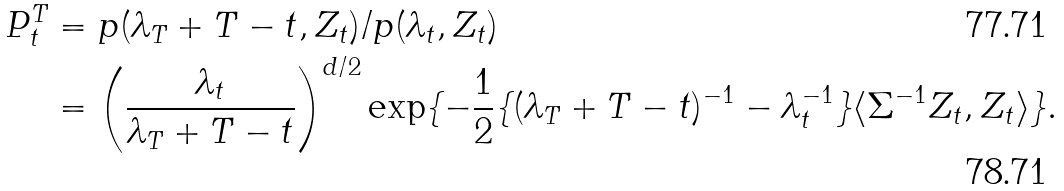Convert formula to latex. <formula><loc_0><loc_0><loc_500><loc_500>P ^ { T } _ { t } & = p ( \lambda _ { T } + T - t , Z _ { t } ) / p ( \lambda _ { t } , Z _ { t } ) \\ & = \left ( \frac { \lambda _ { t } } { \lambda _ { T } + T - t } \right ) ^ { d / 2 } \exp \{ - \frac { 1 } { 2 } \{ ( \lambda _ { T } + T - t ) ^ { - 1 } - \lambda _ { t } ^ { - 1 } \} \langle \Sigma ^ { - 1 } Z _ { t } , Z _ { t } \rangle \} .</formula> 